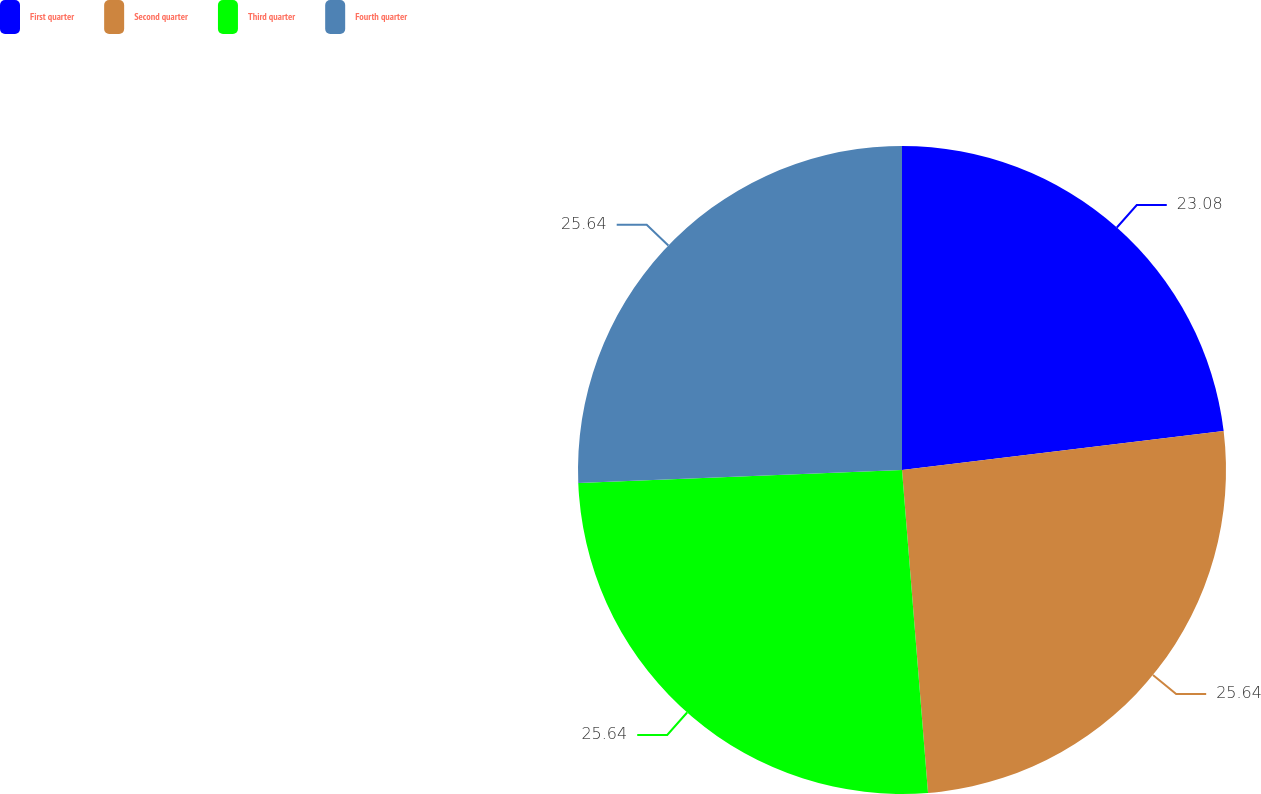Convert chart to OTSL. <chart><loc_0><loc_0><loc_500><loc_500><pie_chart><fcel>First quarter<fcel>Second quarter<fcel>Third quarter<fcel>Fourth quarter<nl><fcel>23.08%<fcel>25.64%<fcel>25.64%<fcel>25.64%<nl></chart> 